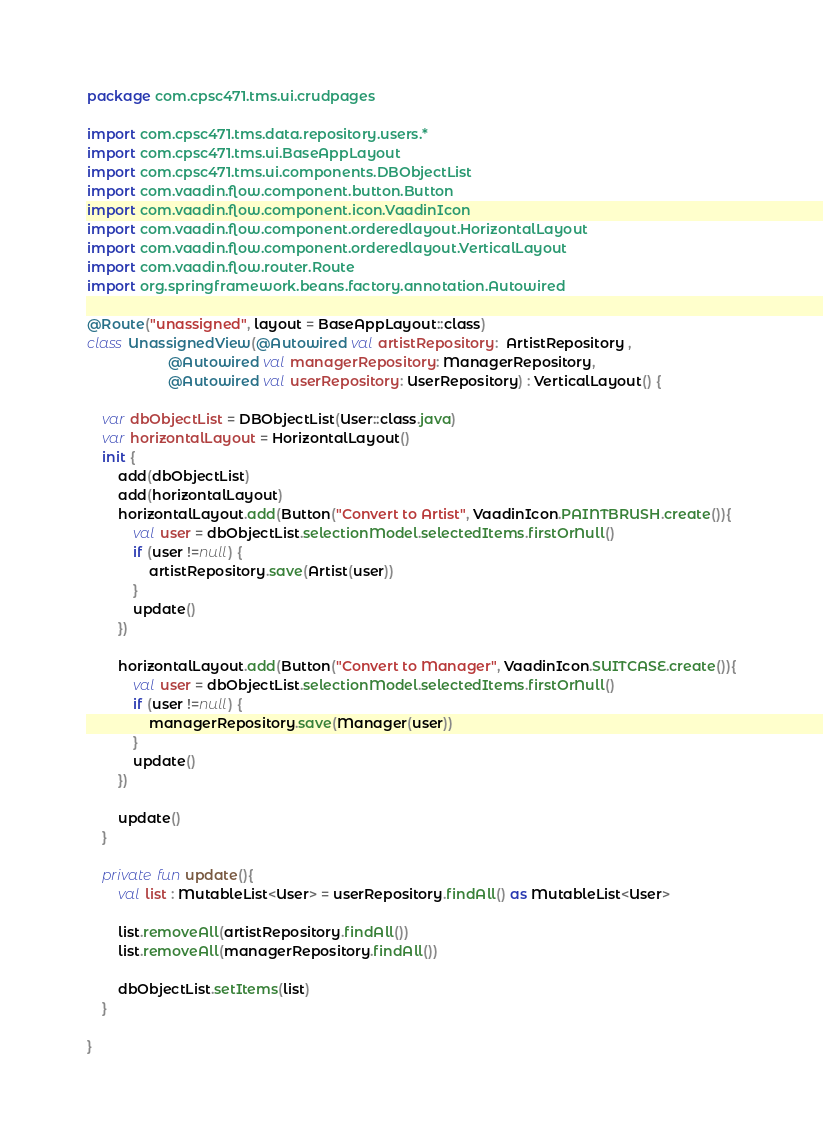Convert code to text. <code><loc_0><loc_0><loc_500><loc_500><_Kotlin_>package com.cpsc471.tms.ui.crudpages

import com.cpsc471.tms.data.repository.users.*
import com.cpsc471.tms.ui.BaseAppLayout
import com.cpsc471.tms.ui.components.DBObjectList
import com.vaadin.flow.component.button.Button
import com.vaadin.flow.component.icon.VaadinIcon
import com.vaadin.flow.component.orderedlayout.HorizontalLayout
import com.vaadin.flow.component.orderedlayout.VerticalLayout
import com.vaadin.flow.router.Route
import org.springframework.beans.factory.annotation.Autowired

@Route("unassigned", layout = BaseAppLayout::class)
class UnassignedView(@Autowired val artistRepository:  ArtistRepository ,
                     @Autowired val managerRepository: ManagerRepository,
                     @Autowired val userRepository: UserRepository) : VerticalLayout() {

    var dbObjectList = DBObjectList(User::class.java)
    var horizontalLayout = HorizontalLayout()
    init {
        add(dbObjectList)
        add(horizontalLayout)
        horizontalLayout.add(Button("Convert to Artist", VaadinIcon.PAINTBRUSH.create()){
            val user = dbObjectList.selectionModel.selectedItems.firstOrNull()
            if (user !=null) {
                artistRepository.save(Artist(user))
            }
            update()
        })

        horizontalLayout.add(Button("Convert to Manager", VaadinIcon.SUITCASE.create()){
            val user = dbObjectList.selectionModel.selectedItems.firstOrNull()
            if (user !=null) {
                managerRepository.save(Manager(user))
            }
            update()
        })

        update()
    }

    private fun update(){
        val list : MutableList<User> = userRepository.findAll() as MutableList<User>

        list.removeAll(artistRepository.findAll())
        list.removeAll(managerRepository.findAll())

        dbObjectList.setItems(list)
    }

}
</code> 